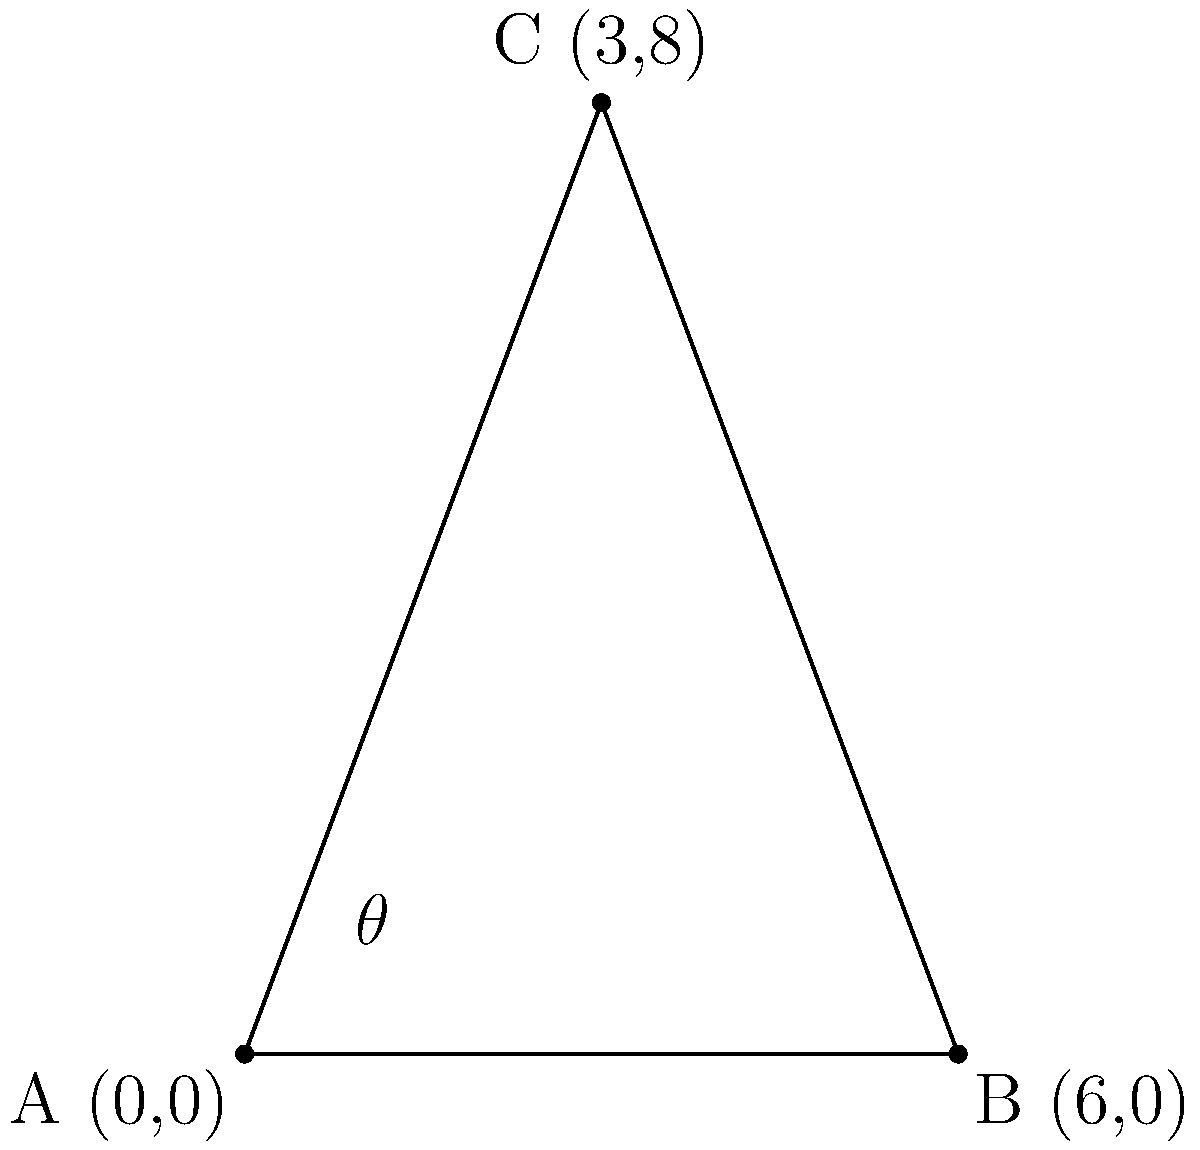In a soccer match, a player is about to take a shot on goal. The ball's position is at point A (0,0), and the two goalposts are located at points B (6,0) and C (3,8). Calculate the angle $\theta$ (in degrees) between the two possible shots from the ball to each goalpost. Round your answer to the nearest degree. To solve this problem, we'll use the law of cosines. Here's a step-by-step approach:

1) First, calculate the lengths of the three sides of the triangle:

   AB = $\sqrt{(6-0)^2 + (0-0)^2} = 6$
   AC = $\sqrt{(3-0)^2 + (8-0)^2} = \sqrt{73}$
   BC = $\sqrt{(3-6)^2 + (8-0)^2} = \sqrt{82}$

2) Now, use the law of cosines to find the angle $\theta$:

   $\cos(\theta) = \frac{AB^2 + AC^2 - BC^2}{2(AB)(AC)}$

3) Substitute the values:

   $\cos(\theta) = \frac{6^2 + (\sqrt{73})^2 - (\sqrt{82})^2}{2(6)(\sqrt{73})}$

4) Simplify:

   $\cos(\theta) = \frac{36 + 73 - 82}{12\sqrt{73}} = \frac{27}{12\sqrt{73}}$

5) Take the inverse cosine (arccos) of both sides:

   $\theta = \arccos(\frac{27}{12\sqrt{73}})$

6) Calculate and convert to degrees:

   $\theta \approx 53.13°$

7) Round to the nearest degree:

   $\theta \approx 53°$
Answer: $53°$ 